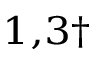<formula> <loc_0><loc_0><loc_500><loc_500>^ { 1 , 3 \dag }</formula> 